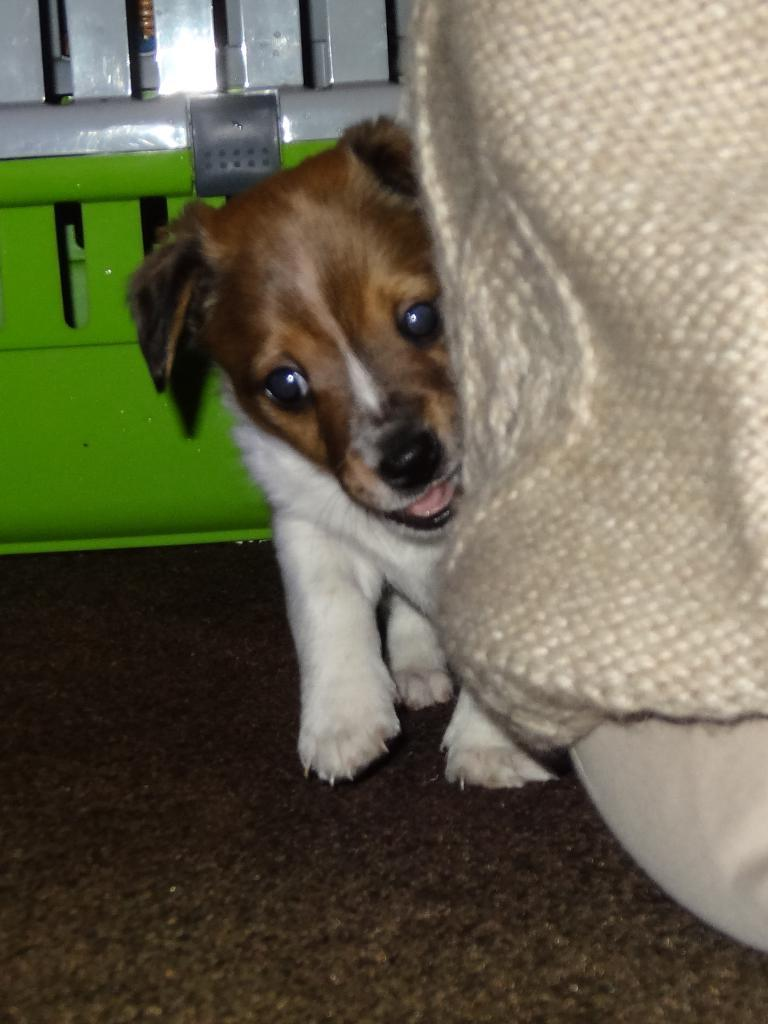What animal is standing in the image? There is a dog standing in the image. What is the position of the person in the image? There is a person sitting in the image. Can you describe the object in the background of the image? Unfortunately, the facts provided do not give any details about the object in the background. What type of drug is the fireman using in the image? There is no fireman or drug present in the image. How does the dog compare to the fireman in terms of size in the image? There is no fireman present in the image, so we cannot make a comparison. 